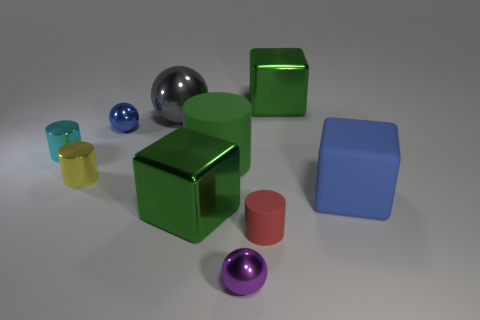There is a blue thing that is left of the block that is behind the small cyan metallic thing; how many cyan objects are right of it?
Make the answer very short. 0. There is a big matte object that is the same shape as the small yellow object; what color is it?
Provide a succinct answer. Green. There is a large green shiny object that is in front of the small cyan cylinder to the left of the metal ball that is to the right of the green rubber thing; what is its shape?
Offer a very short reply. Cube. There is a metal ball that is in front of the gray shiny object and to the left of the small purple thing; what is its size?
Keep it short and to the point. Small. Is the number of tiny purple things less than the number of tiny gray metal cubes?
Your answer should be very brief. No. There is a metal sphere in front of the tiny red cylinder; what size is it?
Keep it short and to the point. Small. There is a tiny metal thing that is on the right side of the tiny yellow metal thing and behind the green rubber object; what shape is it?
Ensure brevity in your answer.  Sphere. What is the size of the red rubber object that is the same shape as the yellow metallic object?
Ensure brevity in your answer.  Small. How many tiny brown spheres are the same material as the blue cube?
Provide a short and direct response. 0. Does the large matte cylinder have the same color as the thing behind the large ball?
Give a very brief answer. Yes. 